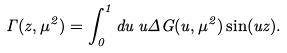Convert formula to latex. <formula><loc_0><loc_0><loc_500><loc_500>\Gamma ( z , \mu ^ { 2 } ) = \int _ { 0 } ^ { 1 } d u \, u \Delta G ( u , \mu ^ { 2 } ) \sin ( u z ) .</formula> 